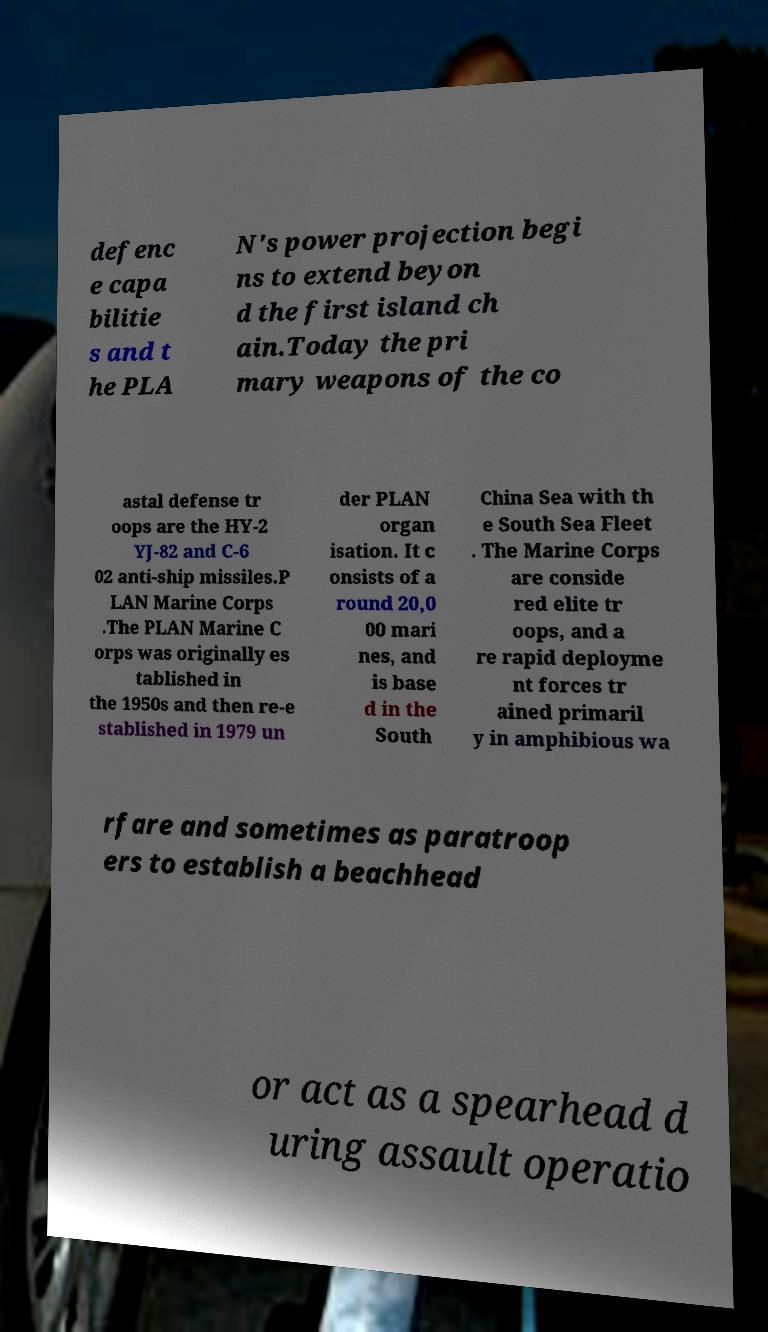There's text embedded in this image that I need extracted. Can you transcribe it verbatim? defenc e capa bilitie s and t he PLA N's power projection begi ns to extend beyon d the first island ch ain.Today the pri mary weapons of the co astal defense tr oops are the HY-2 YJ-82 and C-6 02 anti-ship missiles.P LAN Marine Corps .The PLAN Marine C orps was originally es tablished in the 1950s and then re-e stablished in 1979 un der PLAN organ isation. It c onsists of a round 20,0 00 mari nes, and is base d in the South China Sea with th e South Sea Fleet . The Marine Corps are conside red elite tr oops, and a re rapid deployme nt forces tr ained primaril y in amphibious wa rfare and sometimes as paratroop ers to establish a beachhead or act as a spearhead d uring assault operatio 